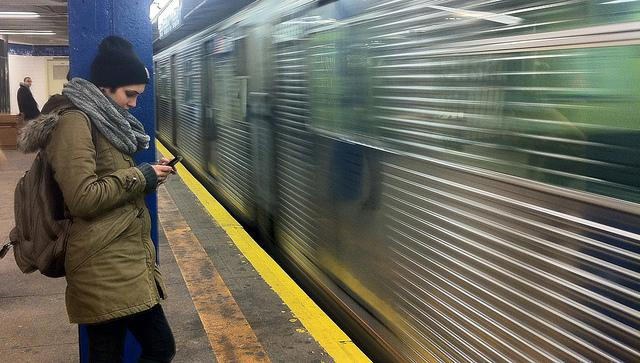What tells people where to stand for safety? Please explain your reasoning. yellow line. The marking indicates where the edge of the platform is. 